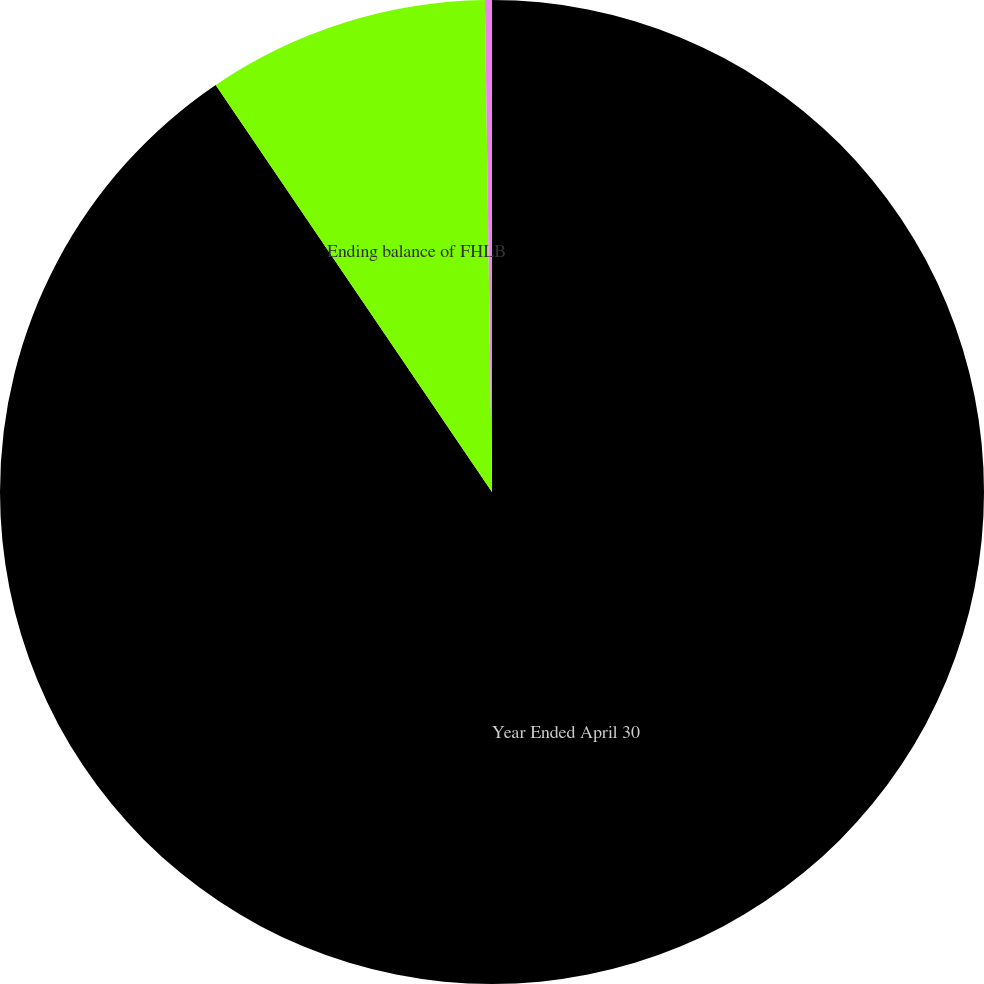Convert chart. <chart><loc_0><loc_0><loc_500><loc_500><pie_chart><fcel>Year Ended April 30<fcel>Ending balance of FHLB<fcel>Average balance of FHLB<nl><fcel>90.51%<fcel>9.26%<fcel>0.23%<nl></chart> 